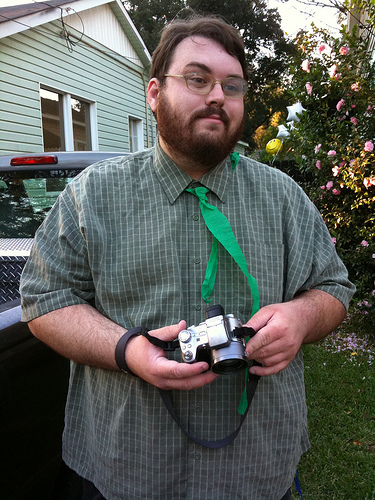Which kind of vehicle is to the left of the camera? To the left of the camera, there is a pickup truck with a visible cargo area at the back. 